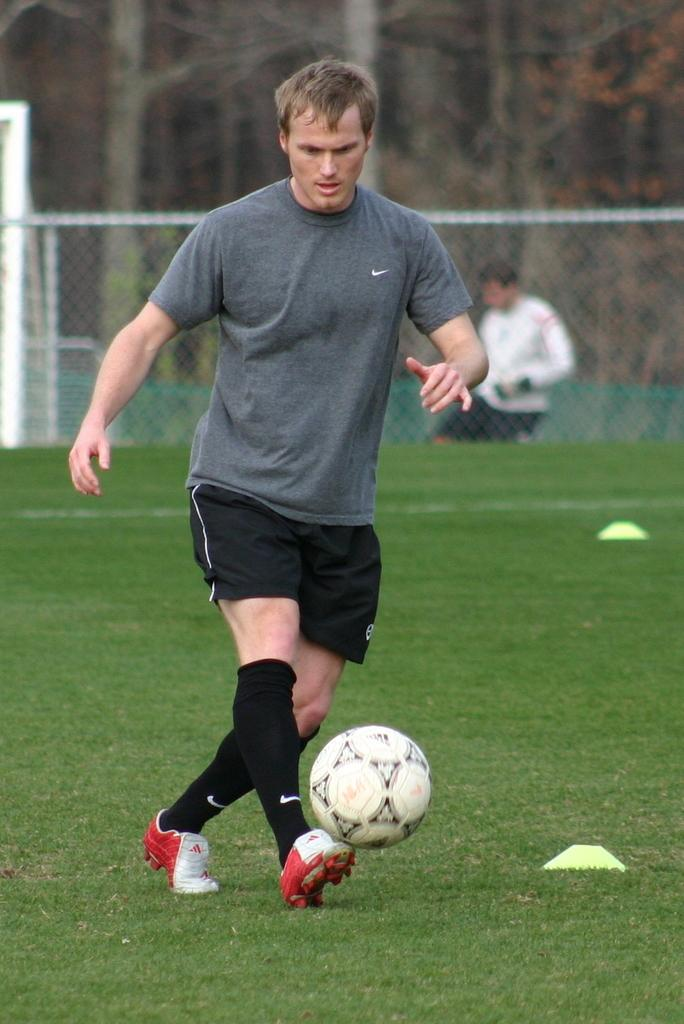Who is in the image? There is a man in the image. What is the man doing in the image? The man is playing with a ball. What type of surface is the man playing on? The ground is grass. What can be seen in the background of the image? There is a mesh and trees in the background of the image. What type of food is the man eating in the image? There is no food present in the image; the man is playing with a ball. How quiet is the environment in the image? The provided facts do not give any information about the noise level in the image, so it cannot be determined. 